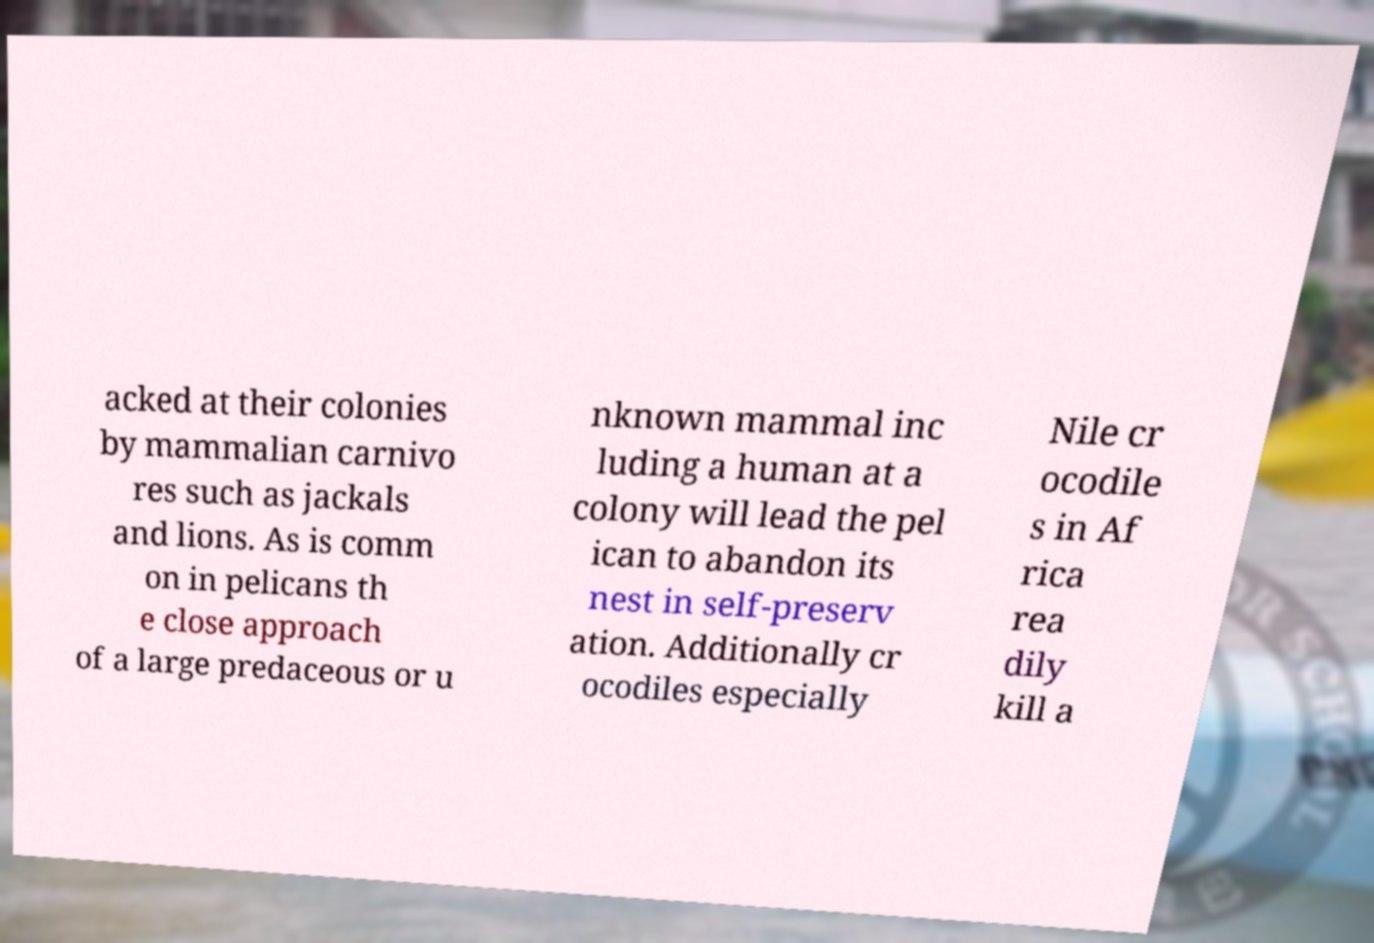Can you accurately transcribe the text from the provided image for me? acked at their colonies by mammalian carnivo res such as jackals and lions. As is comm on in pelicans th e close approach of a large predaceous or u nknown mammal inc luding a human at a colony will lead the pel ican to abandon its nest in self-preserv ation. Additionally cr ocodiles especially Nile cr ocodile s in Af rica rea dily kill a 